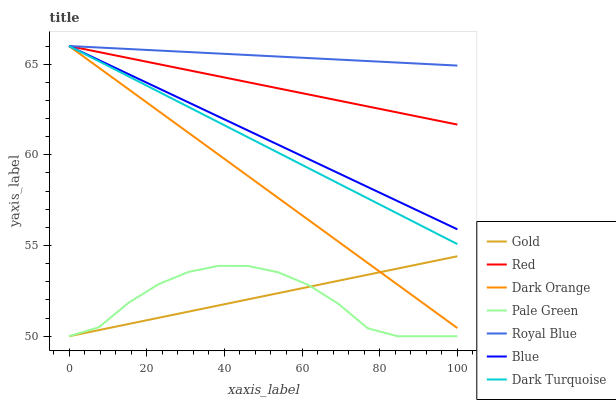Does Dark Orange have the minimum area under the curve?
Answer yes or no. No. Does Dark Orange have the maximum area under the curve?
Answer yes or no. No. Is Dark Orange the smoothest?
Answer yes or no. No. Is Dark Orange the roughest?
Answer yes or no. No. Does Dark Orange have the lowest value?
Answer yes or no. No. Does Gold have the highest value?
Answer yes or no. No. Is Pale Green less than Dark Turquoise?
Answer yes or no. Yes. Is Red greater than Gold?
Answer yes or no. Yes. Does Pale Green intersect Dark Turquoise?
Answer yes or no. No. 